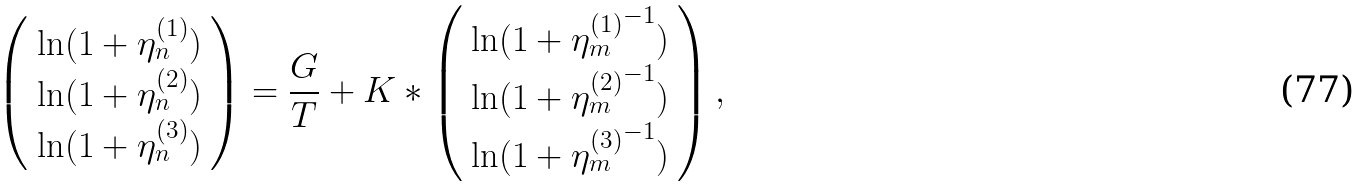<formula> <loc_0><loc_0><loc_500><loc_500>\left ( \begin{array} { c } \ln ( 1 + \eta _ { n } ^ { ( 1 ) } ) \\ \ln ( 1 + \eta _ { n } ^ { ( 2 ) } ) \\ \ln ( 1 + \eta _ { n } ^ { ( 3 ) } ) \end{array} \right ) = \frac { G } { T } + K * \left ( \begin{array} { l } \ln ( 1 + { \eta _ { m } ^ { ( 1 ) } } ^ { - 1 } ) \\ \ln ( 1 + { \eta _ { m } ^ { ( 2 ) } } ^ { - 1 } ) \\ \ln ( 1 + { \eta _ { m } ^ { ( 3 ) } } ^ { - 1 } ) \end{array} \right ) ,</formula> 